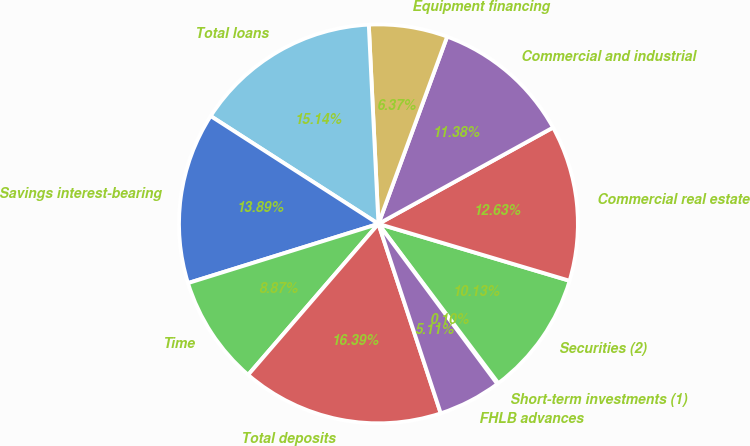Convert chart to OTSL. <chart><loc_0><loc_0><loc_500><loc_500><pie_chart><fcel>Short-term investments (1)<fcel>Securities (2)<fcel>Commercial real estate<fcel>Commercial and industrial<fcel>Equipment financing<fcel>Total loans<fcel>Savings interest-bearing<fcel>Time<fcel>Total deposits<fcel>FHLB advances<nl><fcel>0.1%<fcel>10.13%<fcel>12.63%<fcel>11.38%<fcel>6.37%<fcel>15.14%<fcel>13.89%<fcel>8.87%<fcel>16.39%<fcel>5.11%<nl></chart> 